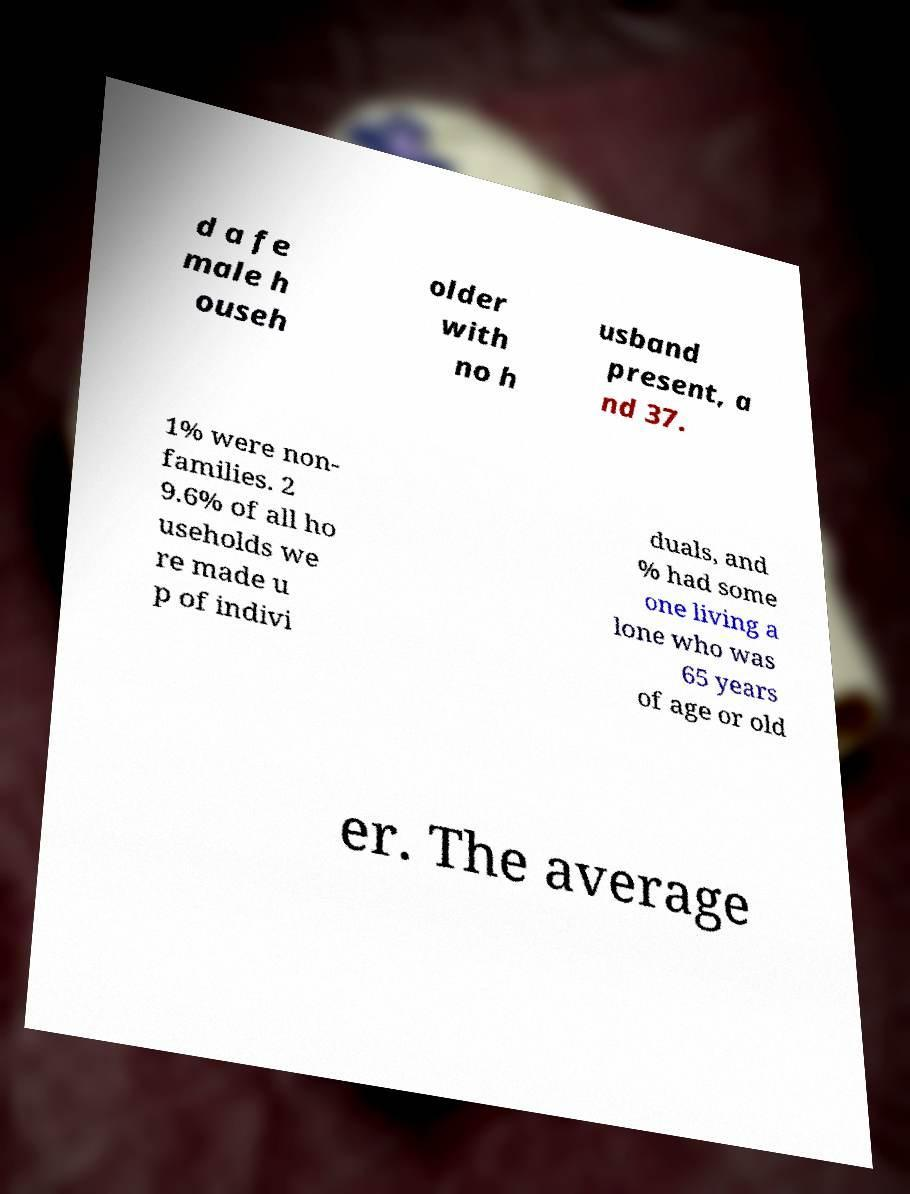Please read and relay the text visible in this image. What does it say? d a fe male h ouseh older with no h usband present, a nd 37. 1% were non- families. 2 9.6% of all ho useholds we re made u p of indivi duals, and % had some one living a lone who was 65 years of age or old er. The average 